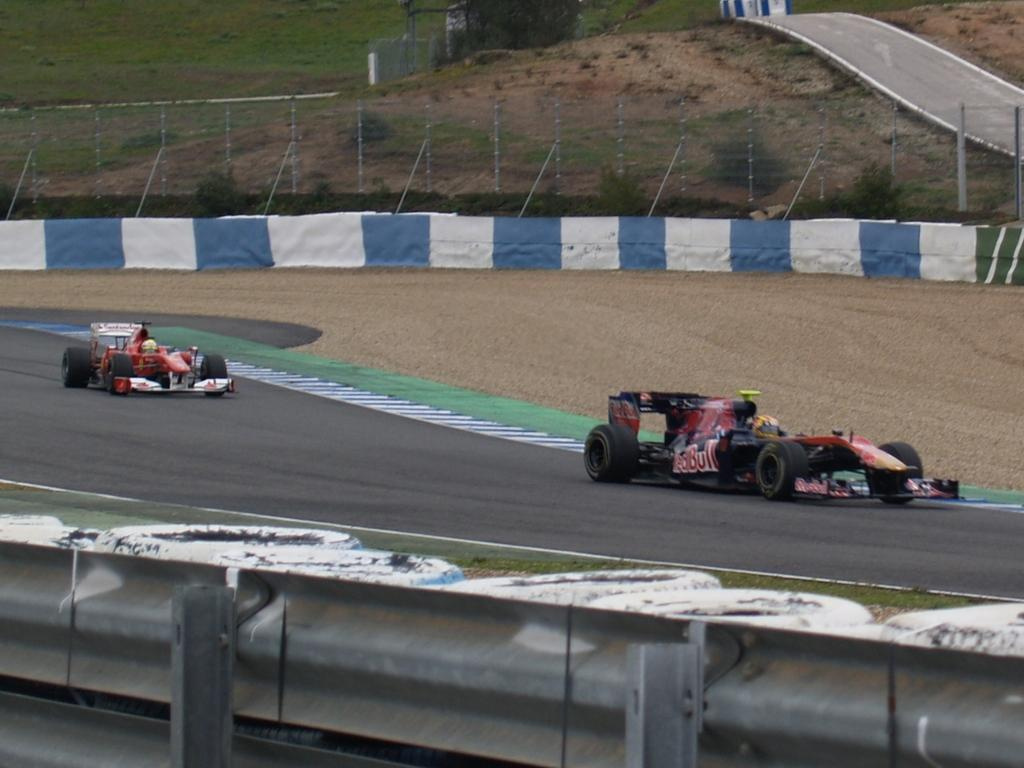What is the main feature of the image? There is a road in the image. What can be seen traveling on the road? There are two cars on the road. What is located in the middle of the image? There is fencing in the middle of the image. What type of vegetation is near the fencing? There are plants near the fencing. What can be seen in the background of the image? There is grass visible in the background of the image. What type of leaf is being used as a window in the image? There is no leaf being used as a window in the image. What type of voyage are the cars taking in the image? The image does not provide information about the destination or purpose of the cars' journey, so it cannot be determined from the image. 